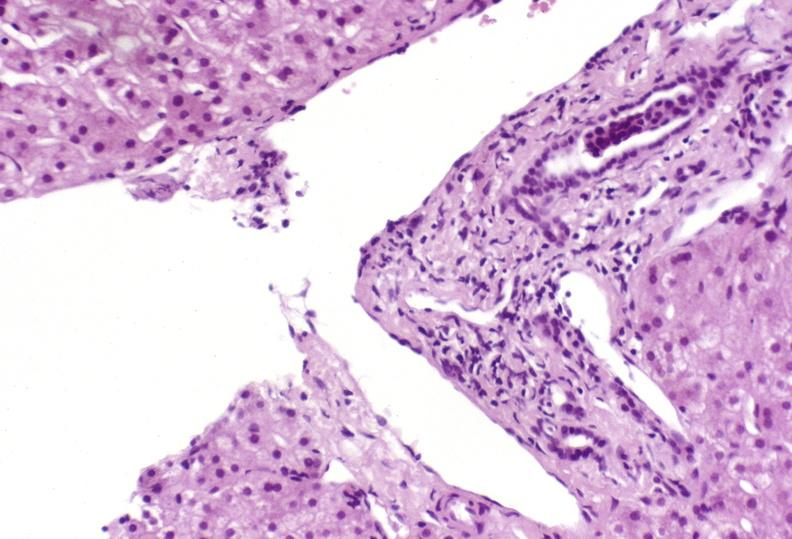does this image show mild acute rejection?
Answer the question using a single word or phrase. Yes 